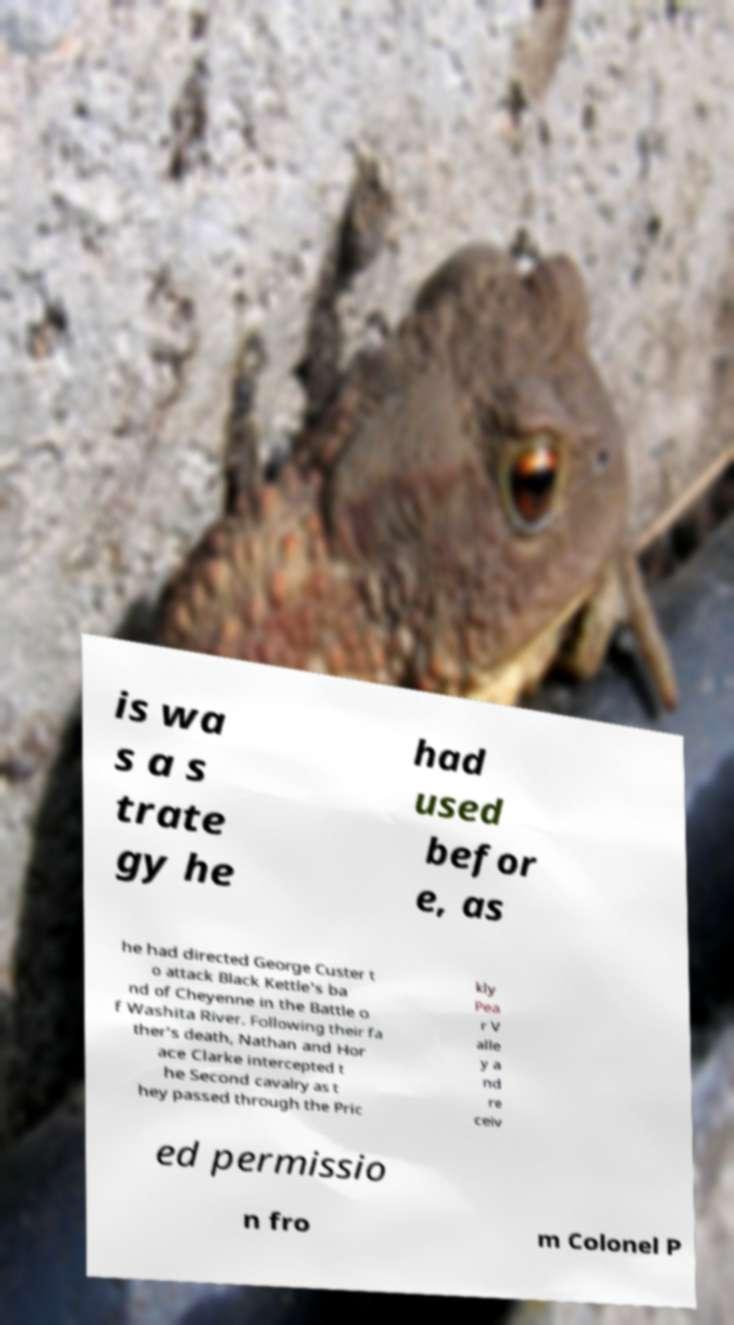Could you extract and type out the text from this image? is wa s a s trate gy he had used befor e, as he had directed George Custer t o attack Black Kettle's ba nd of Cheyenne in the Battle o f Washita River. Following their fa ther's death, Nathan and Hor ace Clarke intercepted t he Second cavalry as t hey passed through the Pric kly Pea r V alle y a nd re ceiv ed permissio n fro m Colonel P 